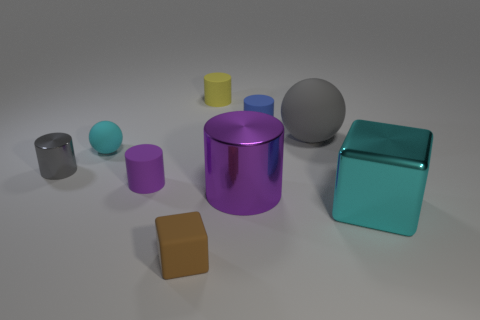There is a big object that is both on the right side of the purple metallic cylinder and on the left side of the cyan metallic object; what is its material?
Offer a terse response. Rubber. What color is the big metallic thing that is the same shape as the yellow rubber thing?
Make the answer very short. Purple. The gray rubber object is what size?
Ensure brevity in your answer.  Large. What is the color of the object that is to the right of the gray object that is behind the gray metallic thing?
Your answer should be compact. Cyan. How many rubber things are both behind the cyan shiny cube and to the right of the tiny purple rubber cylinder?
Give a very brief answer. 3. Is the number of red rubber things greater than the number of brown objects?
Your answer should be compact. No. What is the tiny purple cylinder made of?
Your response must be concise. Rubber. How many large cyan metallic objects are in front of the sphere that is to the right of the cyan rubber sphere?
Your answer should be very brief. 1. There is a large matte object; is its color the same as the small metal object left of the rubber block?
Ensure brevity in your answer.  Yes. What color is the other metal thing that is the same size as the brown object?
Offer a terse response. Gray. 